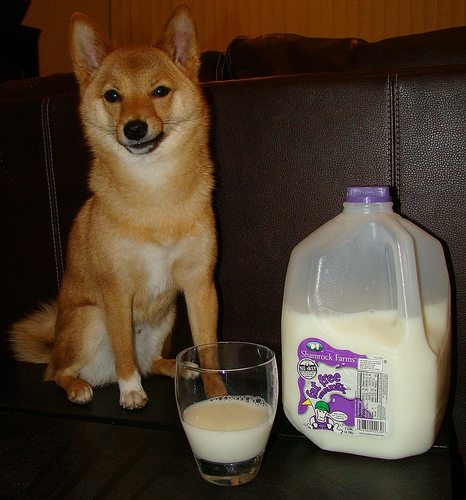<image>
Is there a curtain behind the cap? Yes. From this viewpoint, the curtain is positioned behind the cap, with the cap partially or fully occluding the curtain. Where is the dog in relation to the milk jug? Is it in front of the milk jug? No. The dog is not in front of the milk jug. The spatial positioning shows a different relationship between these objects. 